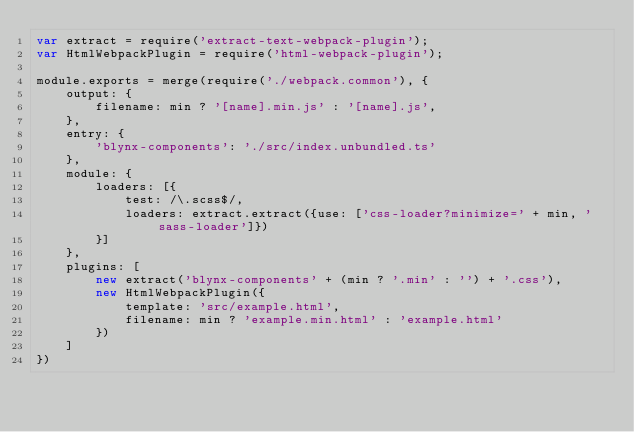<code> <loc_0><loc_0><loc_500><loc_500><_JavaScript_>var extract = require('extract-text-webpack-plugin');
var HtmlWebpackPlugin = require('html-webpack-plugin');

module.exports = merge(require('./webpack.common'), {
    output: {
        filename: min ? '[name].min.js' : '[name].js',
    },
    entry: {
        'blynx-components': './src/index.unbundled.ts'
    },
    module: {
        loaders: [{
            test: /\.scss$/,
            loaders: extract.extract({use: ['css-loader?minimize=' + min, 'sass-loader']})
        }]
    },
    plugins: [
        new extract('blynx-components' + (min ? '.min' : '') + '.css'),
        new HtmlWebpackPlugin({
            template: 'src/example.html',
            filename: min ? 'example.min.html' : 'example.html'
        })
    ]
})</code> 